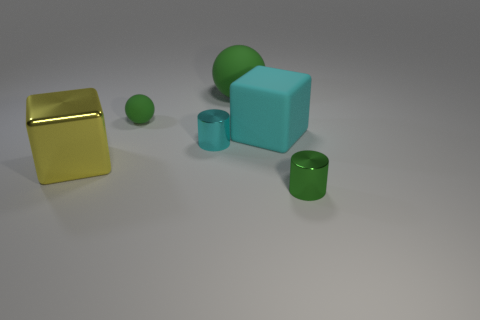Add 3 gray matte objects. How many objects exist? 9 Subtract all spheres. How many objects are left? 4 Subtract all large cyan matte objects. Subtract all large rubber spheres. How many objects are left? 4 Add 5 cubes. How many cubes are left? 7 Add 4 small metal objects. How many small metal objects exist? 6 Subtract 1 green cylinders. How many objects are left? 5 